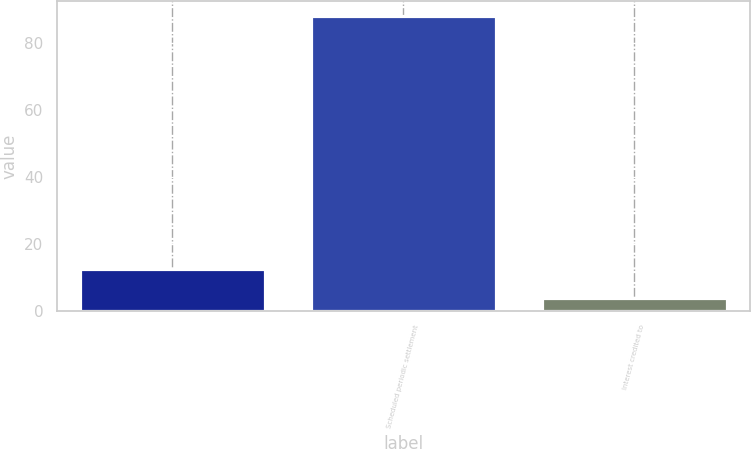<chart> <loc_0><loc_0><loc_500><loc_500><bar_chart><ecel><fcel>Scheduled periodic settlement<fcel>Interest credited to<nl><fcel>12.4<fcel>88<fcel>4<nl></chart> 